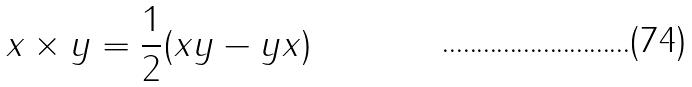Convert formula to latex. <formula><loc_0><loc_0><loc_500><loc_500>x \times y = \frac { 1 } { 2 } ( x y - y x )</formula> 